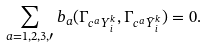Convert formula to latex. <formula><loc_0><loc_0><loc_500><loc_500>\sum _ { a = 1 , 2 , 3 , \prime } b _ { a } ( \Gamma _ { c ^ { a } Y _ { i } ^ { k } } , \Gamma _ { c ^ { a } \bar { Y } _ { i } ^ { k } } ) = 0 .</formula> 